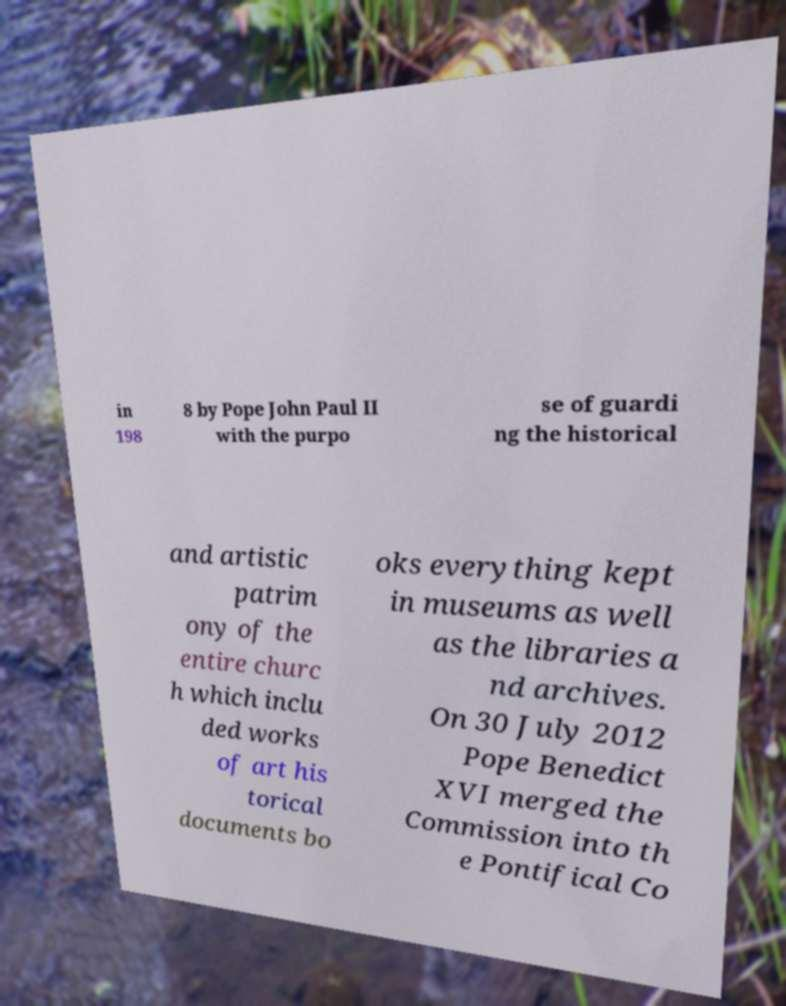What messages or text are displayed in this image? I need them in a readable, typed format. in 198 8 by Pope John Paul II with the purpo se of guardi ng the historical and artistic patrim ony of the entire churc h which inclu ded works of art his torical documents bo oks everything kept in museums as well as the libraries a nd archives. On 30 July 2012 Pope Benedict XVI merged the Commission into th e Pontifical Co 